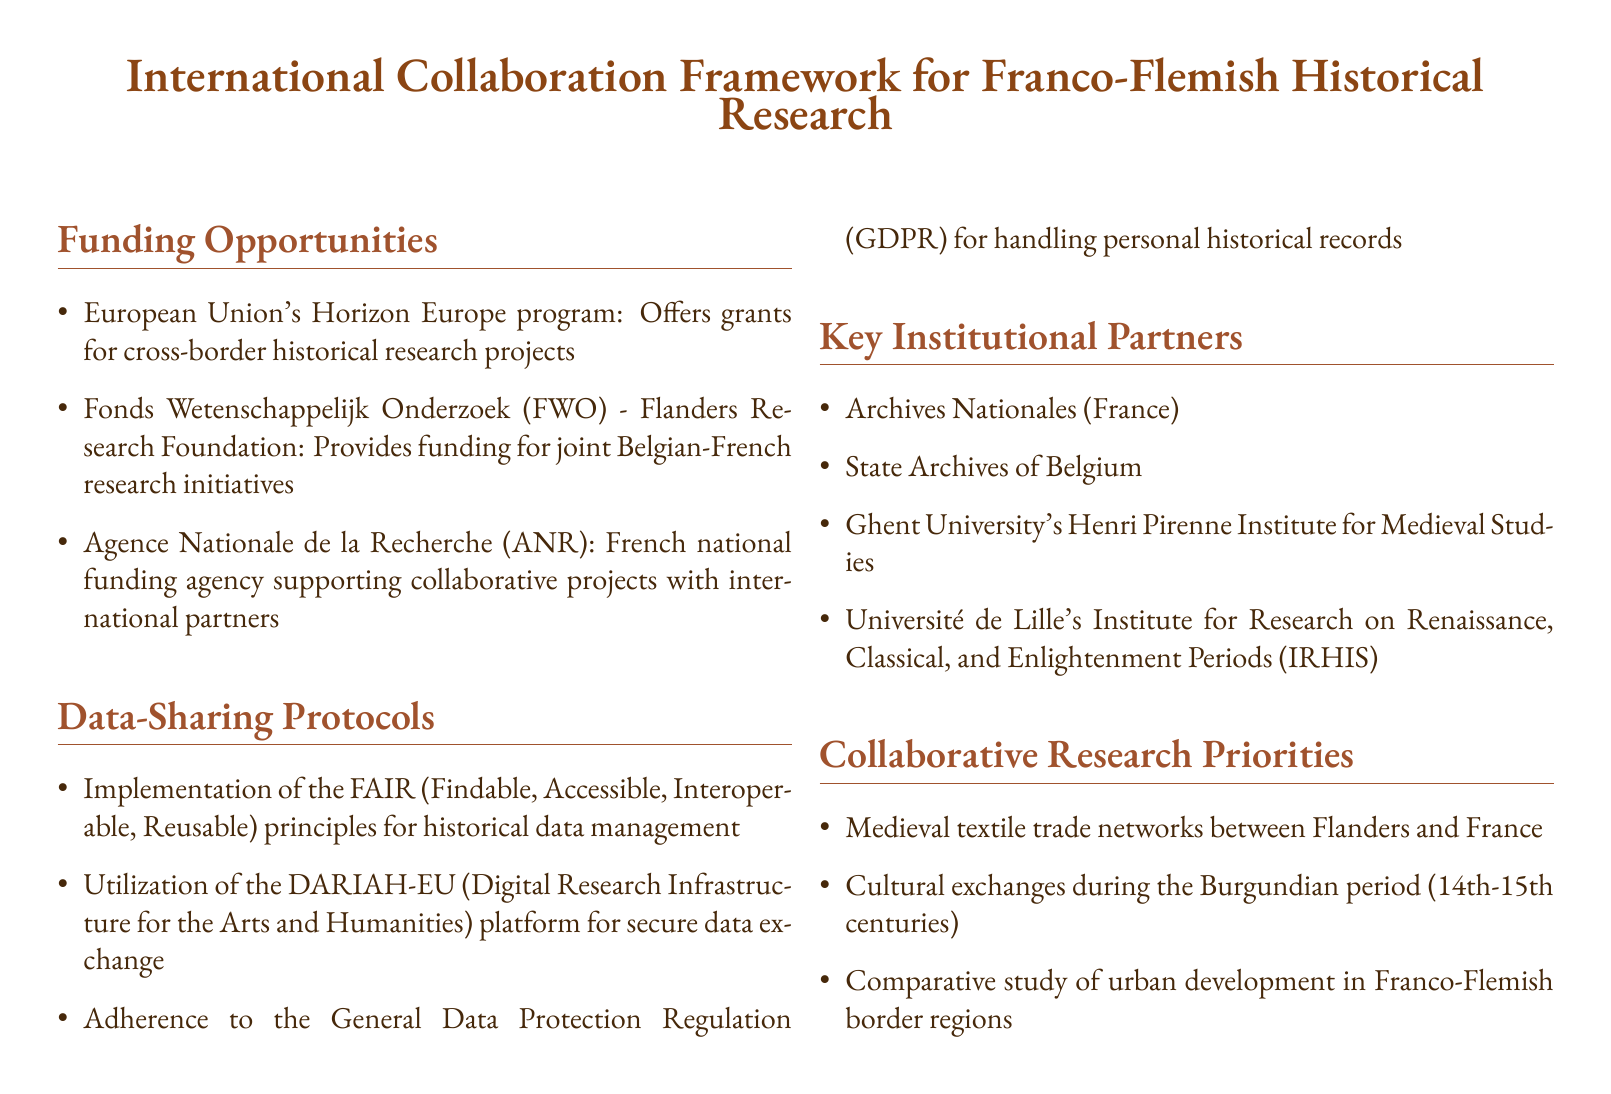What program offers grants for cross-border historical research? The document states that the European Union's Horizon Europe program offers grants for cross-border historical research projects.
Answer: Horizon Europe What is the funding agency supporting collaborative projects with international partners in France? The document mentions the Agence Nationale de la Recherche (ANR) as the French national funding agency supporting collaborative projects.
Answer: Agence Nationale de la Recherche (ANR) What principle is emphasized for historical data management in the data-sharing protocols? The document states that the FAIR principles are implemented for historical data management in the data-sharing protocols.
Answer: FAIR Name one key institutional partner listed in the document. The document lists several key institutional partners, one of which is Archives Nationales.
Answer: Archives Nationales What is one of the collaborative research priorities related to medieval trade? The document indicates that a collaborative research priority is the medieval textile trade networks between Flanders and France.
Answer: Medieval textile trade networks How many institutional partners are mentioned in the document? The document lists four key institutional partners under "Key Institutional Partners."
Answer: Four What does GDPR stand for in the context of data-sharing protocols? According to the document, GDPR refers to the General Data Protection Regulation relevant for handling personal historical records.
Answer: General Data Protection Regulation What platform is utilized for secure data exchange? The document states that the DARIAH-EU platform is utilized for secure data exchange.
Answer: DARIAH-EU List one collaborative research priority concerning cultural exchanges. The document identifies cultural exchanges during the Burgundian period in the collaborative research priorities.
Answer: Cultural exchanges during the Burgundian period 